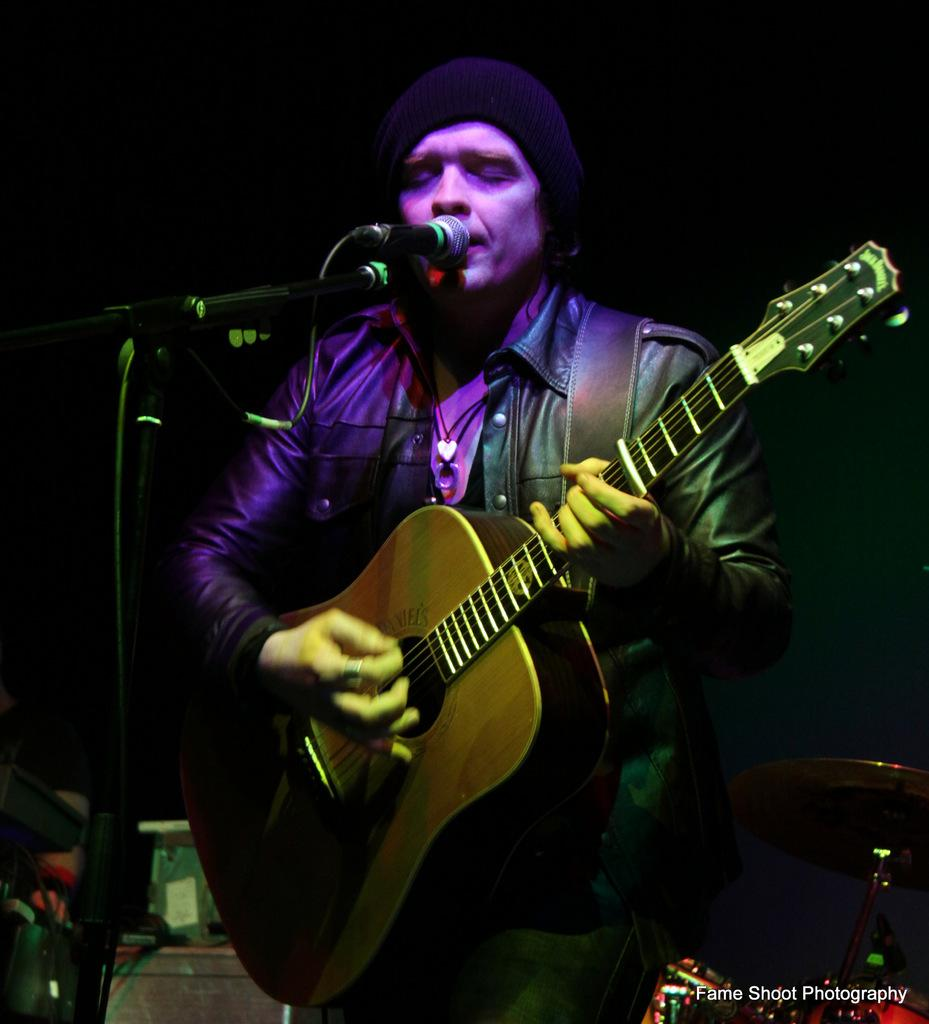What is the main subject of the image? There is a person in the image. What is the person doing in the image? The person is standing, playing a guitar, using a microphone, and singing a song. What type of badge is the person wearing in the image? There is no badge visible in the image. What kind of truck can be seen in the background of the image? There is no truck present in the image. 